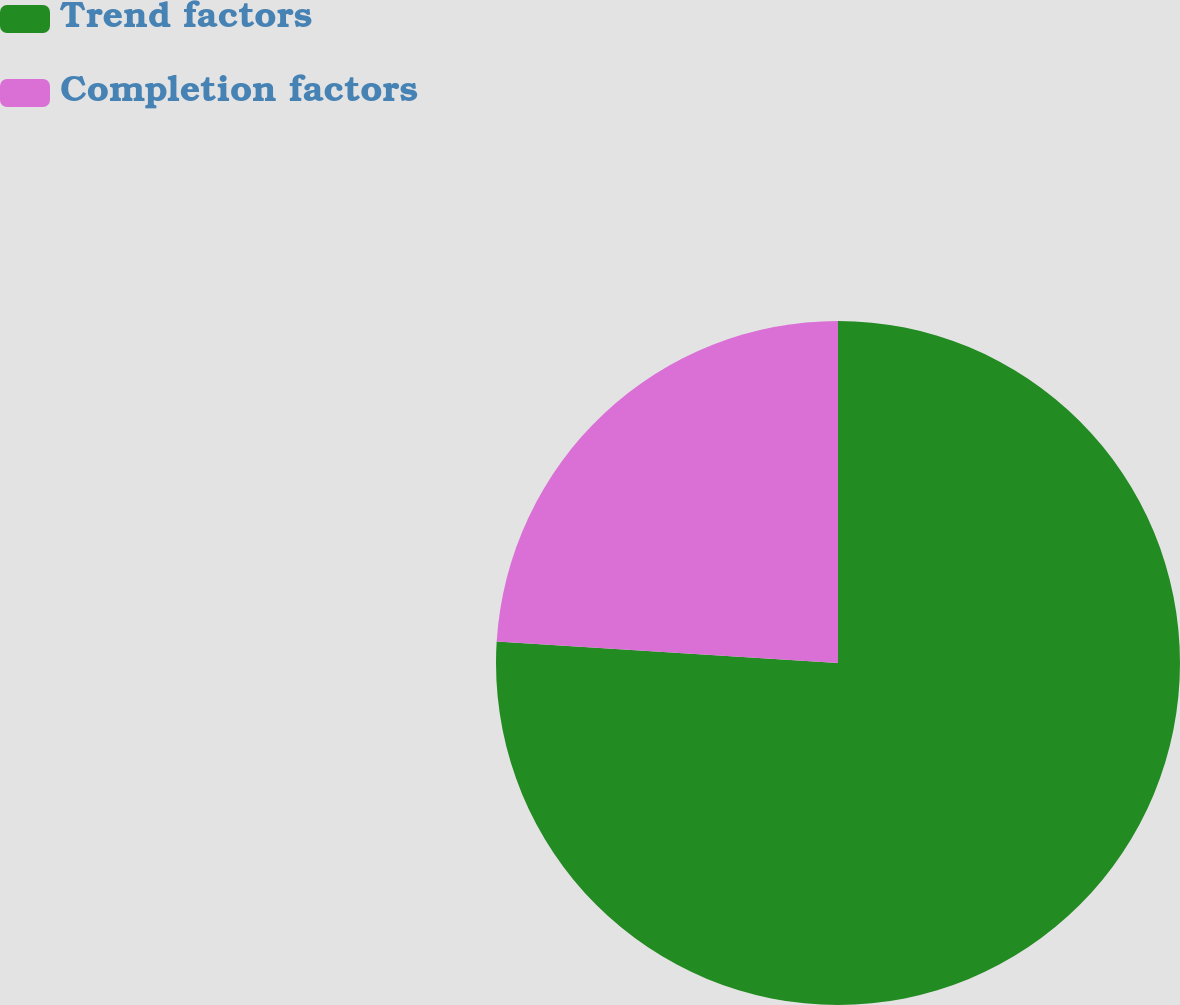Convert chart. <chart><loc_0><loc_0><loc_500><loc_500><pie_chart><fcel>Trend factors<fcel>Completion factors<nl><fcel>76.0%<fcel>24.0%<nl></chart> 